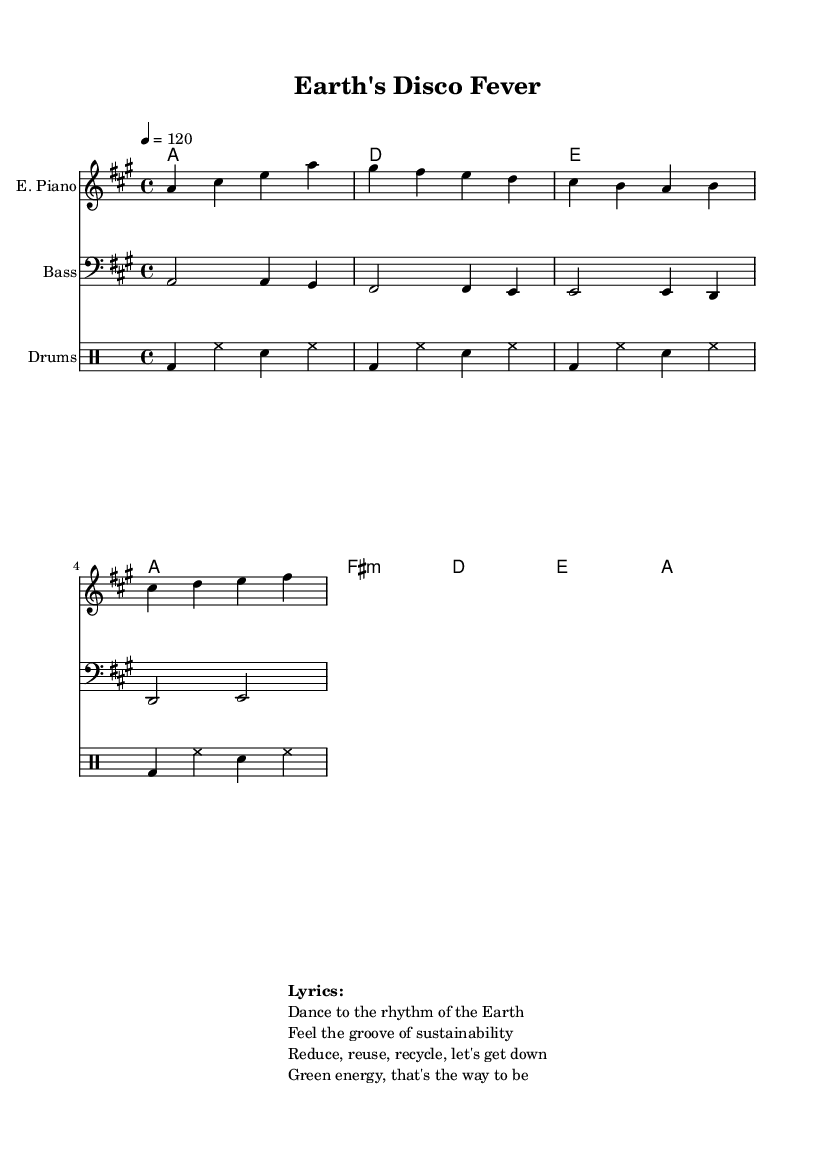What is the key signature of this music? The key signature indicates the scale used in the piece, which is shown at the beginning of the staff. In this case, it shows 3 sharps, corresponding to A major.
Answer: A major What is the time signature of this music? The time signature is indicated at the beginning of the staff. Here, it displays a "4/4," which means there are four beats in each measure and the quarter note gets one beat.
Answer: 4/4 What is the tempo marking of this music? The tempo can be found in the global section, and it indicates the speed of the music. Here it states "4 = 120," meaning the quarter note should be played at 120 beats per minute.
Answer: 120 How many measures are present in the electric piano part? By counting the vertical lines separating groups of notes, the number of measures in the electric piano part can be determined. There are four measures shown in this section.
Answer: 4 What is the name of the style of this music? The style of the music is determined by its upbeat rhythms, repetitive patterns, and danceable groove. The title "Earth's Disco Fever" and the lyrics suggest it falls under Disco, specifically focusing on environmental awareness.
Answer: Disco What chord follows the first measure in the chord chart? In the chord chart, each measure corresponds with specific chord names. The first measure indicates it starts with the A major chord.
Answer: A What is the theme highlighted in the lyrics? The lyrics focus on environmental sustainability and awareness, with phrases promoting actions such as reducing, reusing, and recycling while connecting them to the dance rhythm.
Answer: Sustainability 